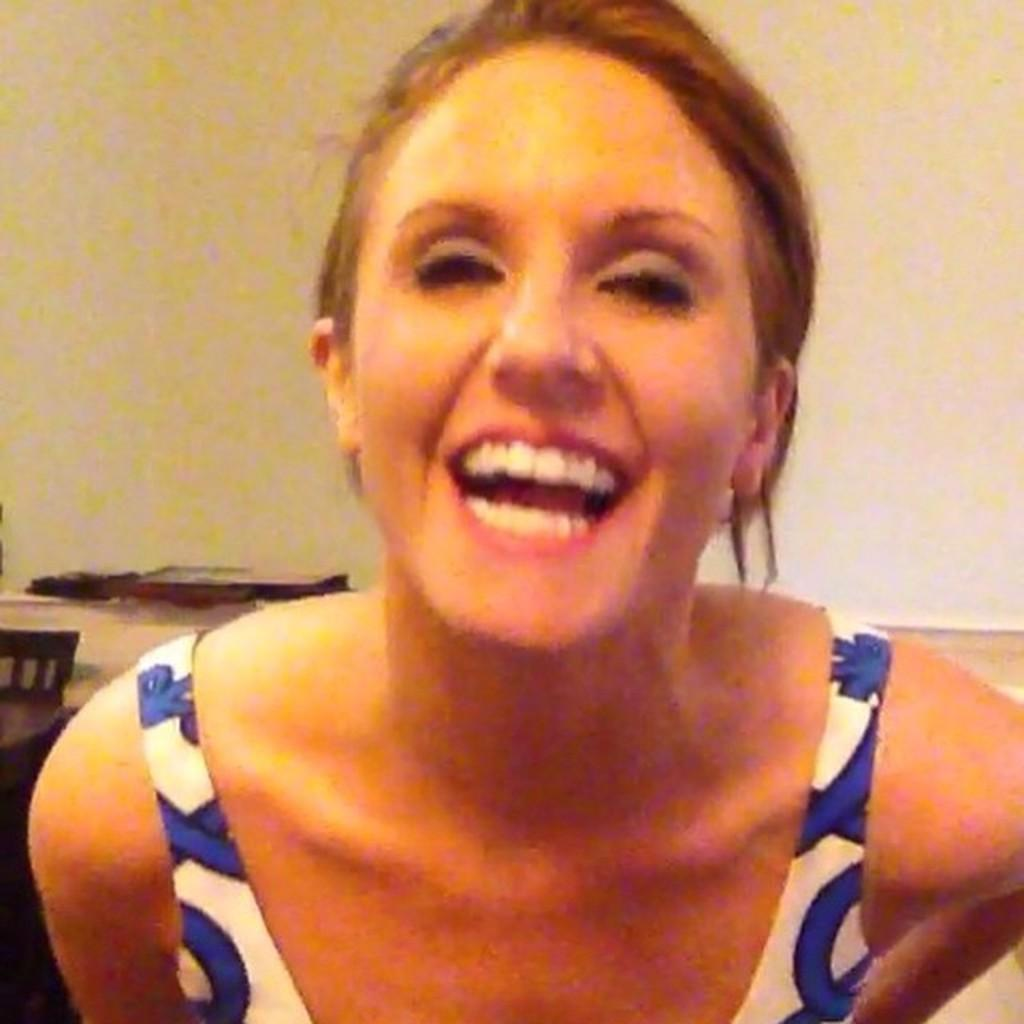Who is present in the image? There is a woman in the image. What is the woman doing in the image? The woman is smiling. What can be seen on the left side of the image? There is an object on the left side of the image. What is the color of the object on the left side of the image? The object is brown in color. What type of soup is being served in the image? There is no soup present in the image. How many sand castles can be seen in the image? There is no sand or sand castles present in the image. 